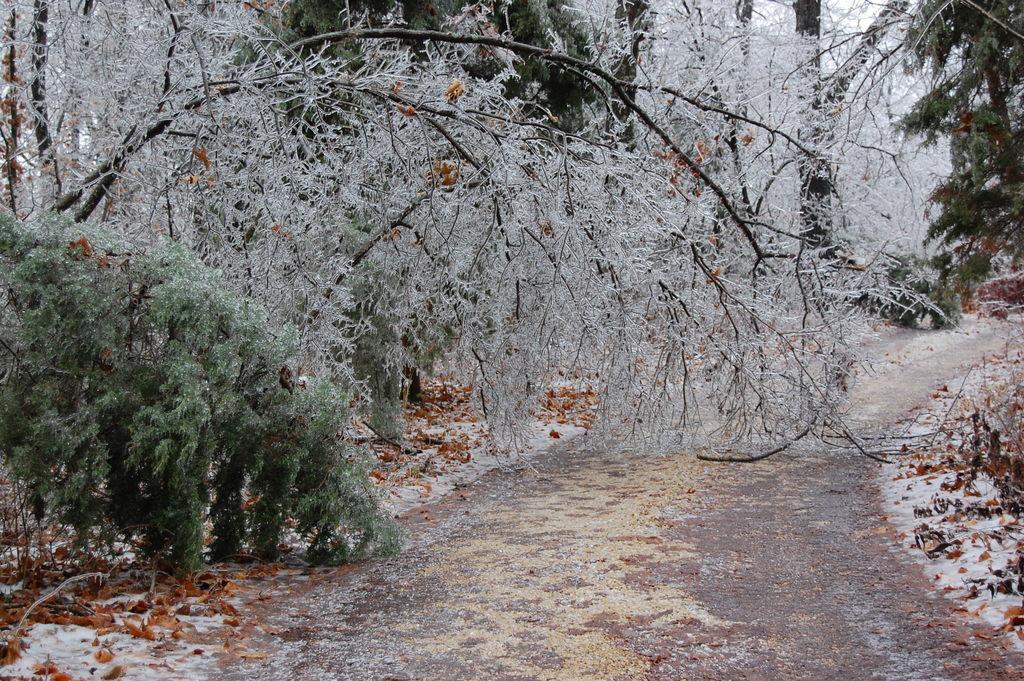Describe this image in one or two sentences. This image consists of many trees and plants. At the bottom, there is a road. 